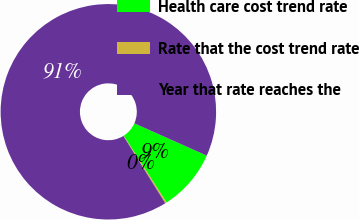Convert chart. <chart><loc_0><loc_0><loc_500><loc_500><pie_chart><fcel>Health care cost trend rate<fcel>Rate that the cost trend rate<fcel>Year that rate reaches the<nl><fcel>9.25%<fcel>0.22%<fcel>90.52%<nl></chart> 